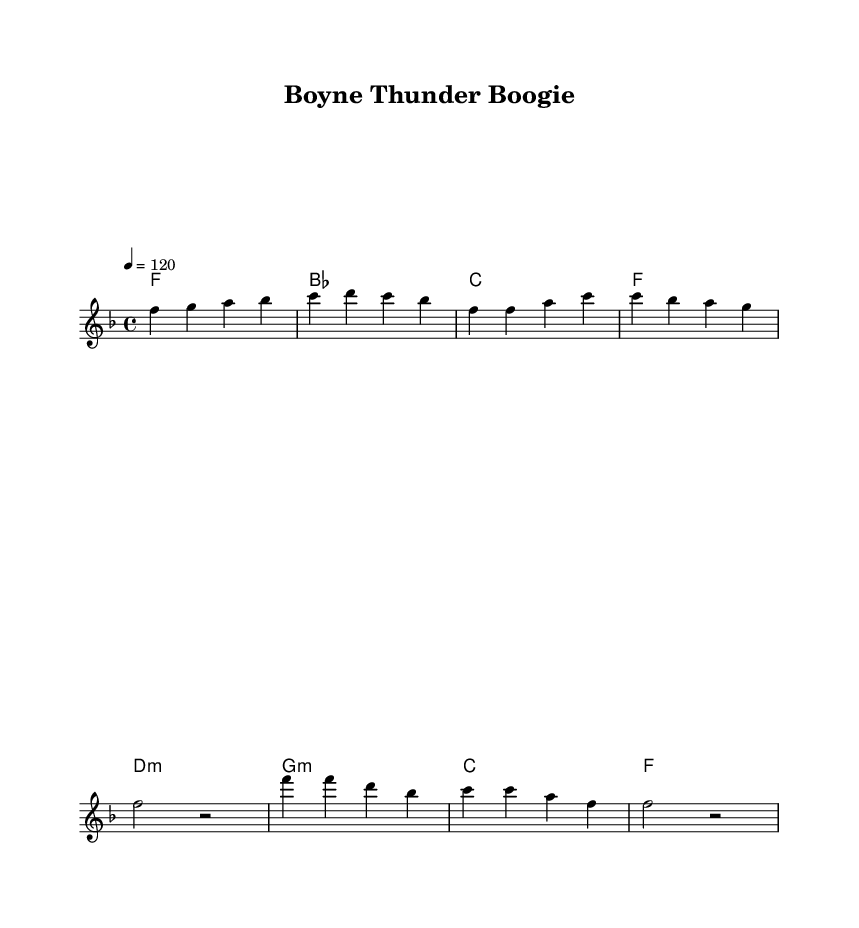What is the key signature of this music? The key signature is F major, which has one flat (B flat). This is identified in the global settings of the sheet music where it specifies the key signature.
Answer: F major What is the time signature of this music? The time signature is 4/4, which is indicated in the global settings right after the key signature, showing that there are four beats in each measure.
Answer: 4/4 What is the tempo marking of this piece? The tempo marking is quarter note equals 120, written in the global settings to indicate the speed at which the piece should be played.
Answer: 120 How many measures are in the verse section? The verse section is made up of four measures, which can be counted from the melody section as it has clearly delineated measures in the notation.
Answer: 4 What is the first note of the chorus? The first note of the chorus is F, which is the note indicated at the start of the chorus melody in the musical notation.
Answer: F What is the lyrical theme of the chorus? The lyrical theme of the chorus centers around celebration and community, as it repeatedly mentions "Boyne Thunder" and "Poker Run," emphasizing festivity and enjoyment.
Answer: Celebration How does the harmonic structure of the piece contribute to its disco feel? The harmonic structure features diatonic chords that create a bright and danceable energy typical of disco music. The use of major chords and variations gives it an uplifting and interactive vibe conducive to boogie.
Answer: Brightness 